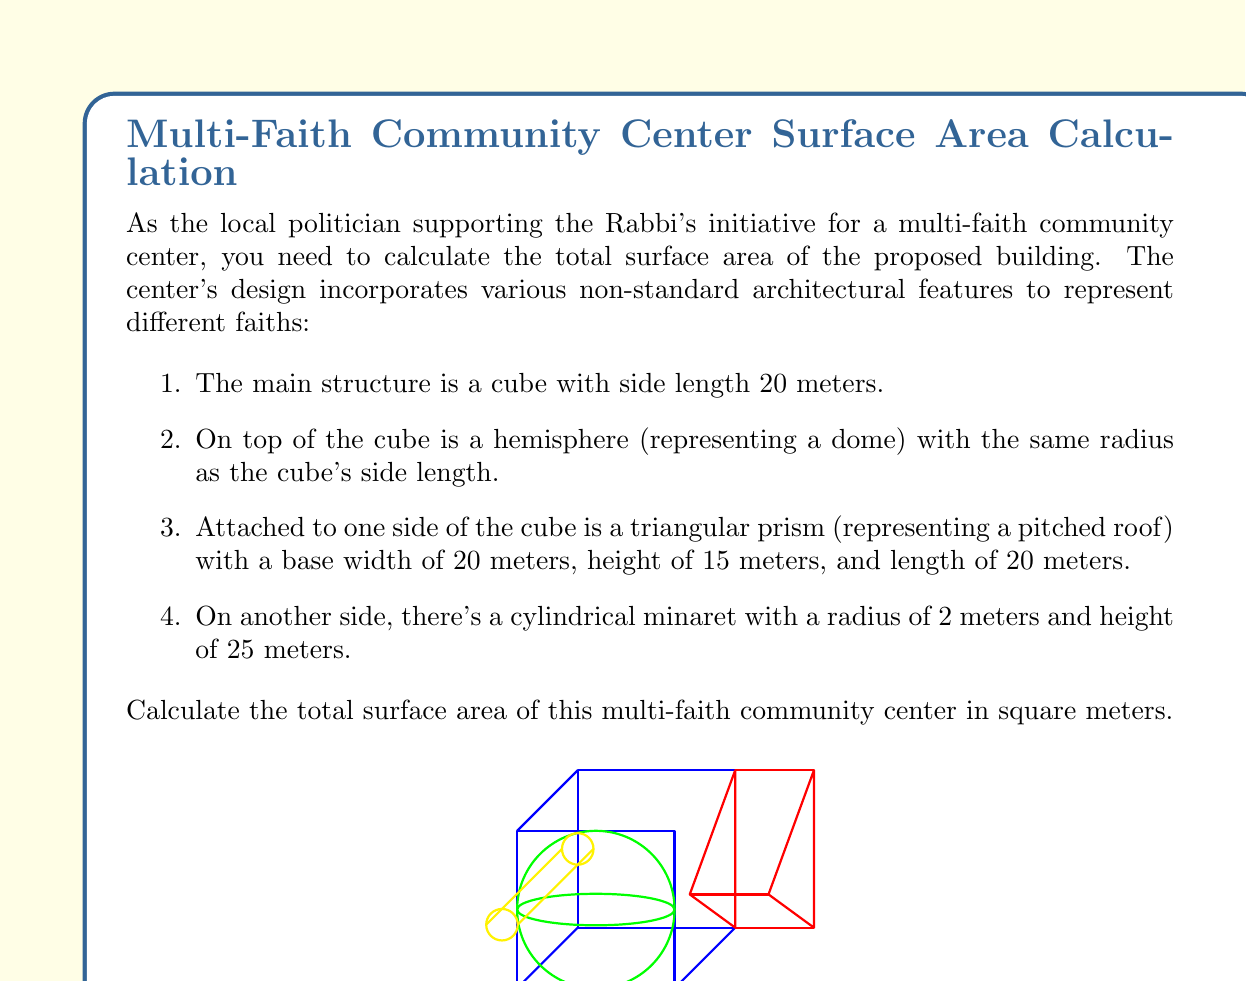What is the answer to this math problem? Let's calculate the surface area for each component:

1. Cube:
   Surface area = $6s^2$ where $s$ is the side length
   $SA_{cube} = 6 \cdot 20^2 = 2400$ m²

2. Hemisphere:
   Surface area = $2\pi r^2$ where $r$ is the radius
   $SA_{hemisphere} = 2\pi \cdot 20^2 = 2513.27$ m²

3. Triangular Prism:
   - Rectangle base: $20 \cdot 20 = 400$ m²
   - Two rectangular sides: $2 \cdot (20 \cdot 15) = 600$ m²
   - Two triangular ends: $2 \cdot (\frac{1}{2} \cdot 20 \cdot 15) = 300$ m²
   $SA_{prism} = 400 + 600 + 300 = 1300$ m²

4. Cylindrical Minaret:
   - Lateral surface area: $2\pi rh$ where $r$ is radius and $h$ is height
   - Circular top: $\pi r^2$
   $SA_{cylinder} = 2\pi \cdot 2 \cdot 25 + \pi \cdot 2^2 = 314.16 + 12.57 = 326.73$ m²

5. Subtractions:
   We need to subtract the areas where components intersect:
   - Cube-Hemisphere: $\pi r^2 = \pi \cdot 20^2 = 1256.64$ m²
   - Cube-Prism: $20 \cdot 20 = 400$ m²
   - Cube-Cylinder: $2 \cdot 2 \cdot 20 = 80$ m²

Total surface area:
$$\begin{align*}
SA_{total} &= SA_{cube} + SA_{hemisphere} + SA_{prism} + SA_{cylinder} - SA_{intersections} \\
&= 2400 + 2513.27 + 1300 + 326.73 - (1256.64 + 400 + 80) \\
&= 6540 - 1736.64 \\
&= 4803.36 \text{ m²}
\end{align*}$$
Answer: $4803.36$ m² 